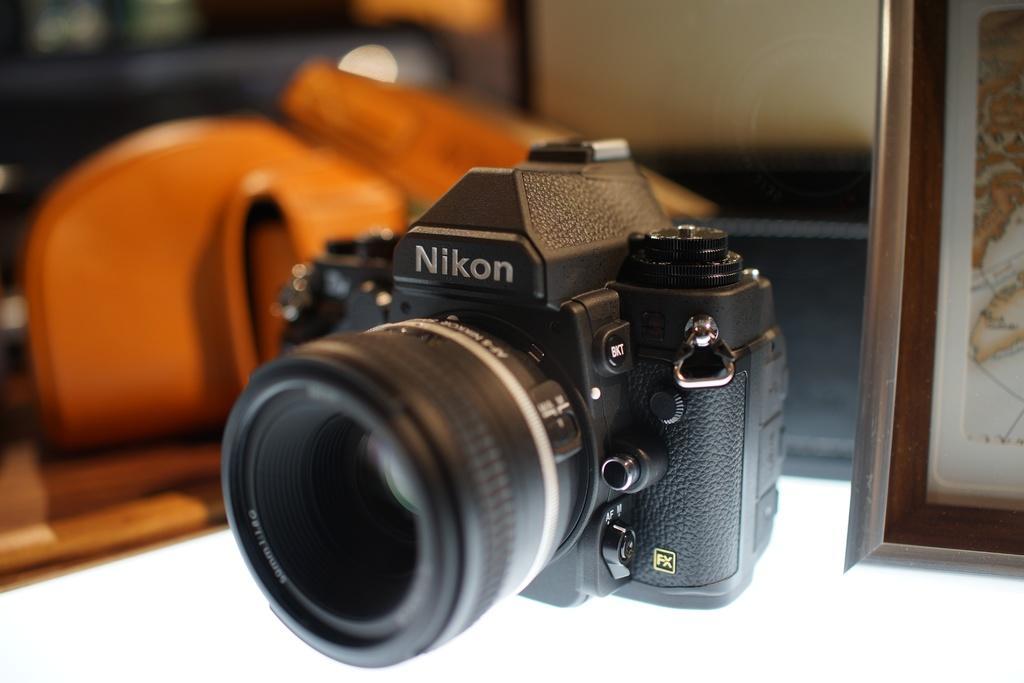Please provide a concise description of this image. In this image we can see a camera. There is a photo frame at the right side of the image. We can see few objects at the left side of the image. 